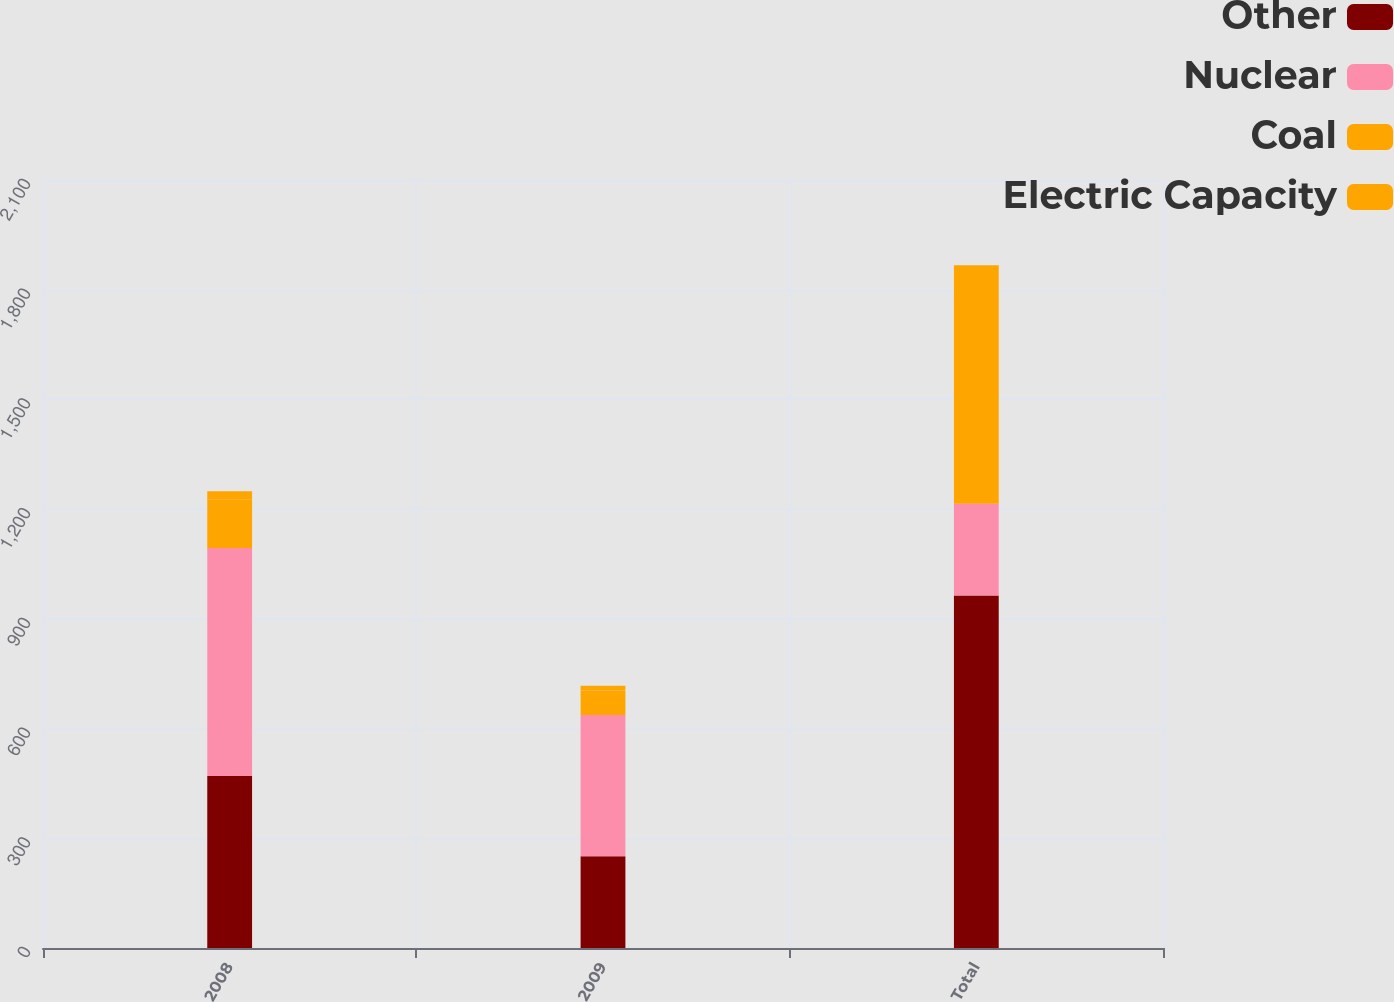<chart> <loc_0><loc_0><loc_500><loc_500><stacked_bar_chart><ecel><fcel>2008<fcel>2009<fcel>Total<nl><fcel>Other<fcel>470<fcel>251<fcel>964<nl><fcel>Nuclear<fcel>624<fcel>386<fcel>251<nl><fcel>Coal<fcel>133<fcel>67<fcel>617<nl><fcel>Electric Capacity<fcel>22<fcel>13<fcel>35<nl></chart> 